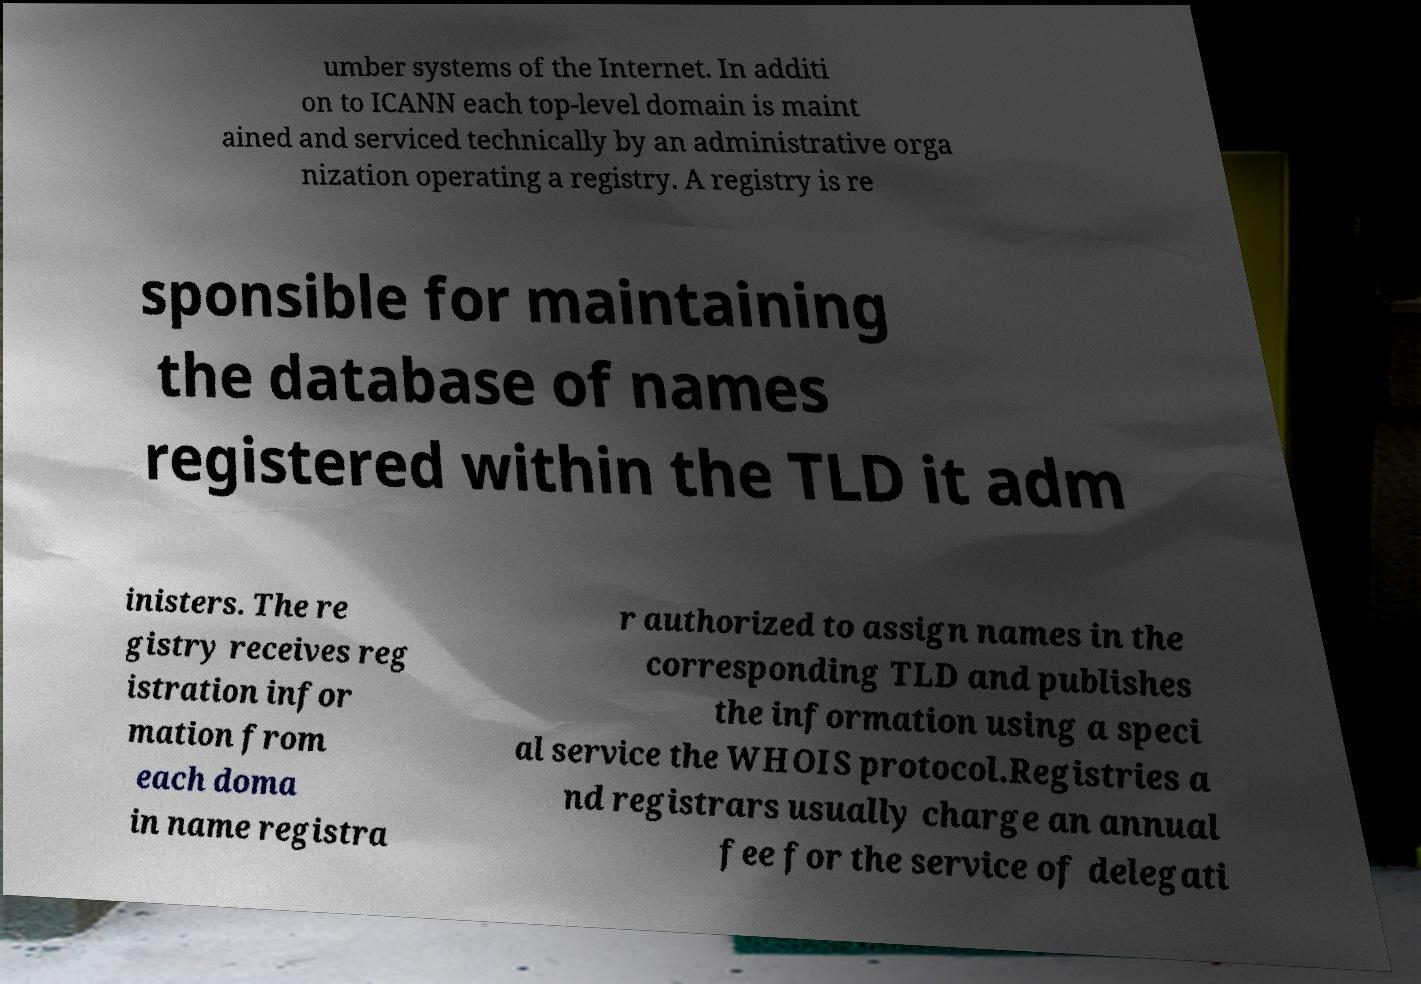Could you extract and type out the text from this image? umber systems of the Internet. In additi on to ICANN each top-level domain is maint ained and serviced technically by an administrative orga nization operating a registry. A registry is re sponsible for maintaining the database of names registered within the TLD it adm inisters. The re gistry receives reg istration infor mation from each doma in name registra r authorized to assign names in the corresponding TLD and publishes the information using a speci al service the WHOIS protocol.Registries a nd registrars usually charge an annual fee for the service of delegati 